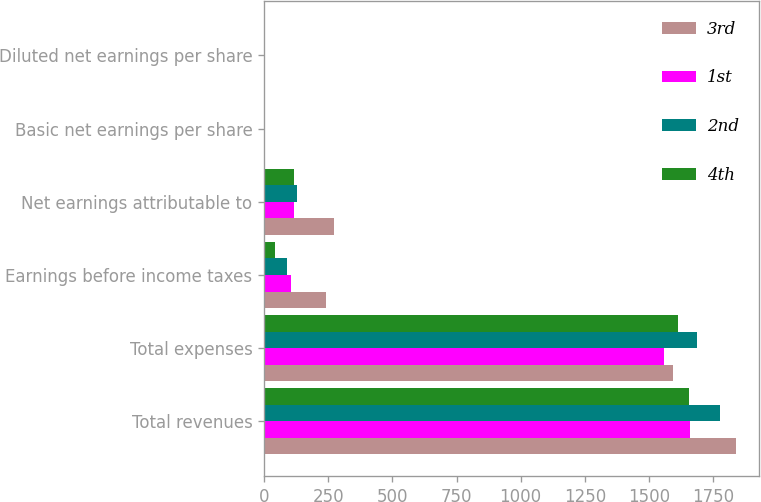Convert chart to OTSL. <chart><loc_0><loc_0><loc_500><loc_500><stacked_bar_chart><ecel><fcel>Total revenues<fcel>Total expenses<fcel>Earnings before income taxes<fcel>Net earnings attributable to<fcel>Basic net earnings per share<fcel>Diluted net earnings per share<nl><fcel>3rd<fcel>1837.7<fcel>1595.4<fcel>242.3<fcel>273.7<fcel>1.51<fcel>1.48<nl><fcel>1st<fcel>1660.4<fcel>1556.8<fcel>103.6<fcel>114.9<fcel>0.63<fcel>0.62<nl><fcel>2nd<fcel>1778.5<fcel>1688.2<fcel>90.3<fcel>127.6<fcel>0.7<fcel>0.68<nl><fcel>4th<fcel>1657.4<fcel>1614.2<fcel>43.2<fcel>117.3<fcel>0.64<fcel>0.63<nl></chart> 